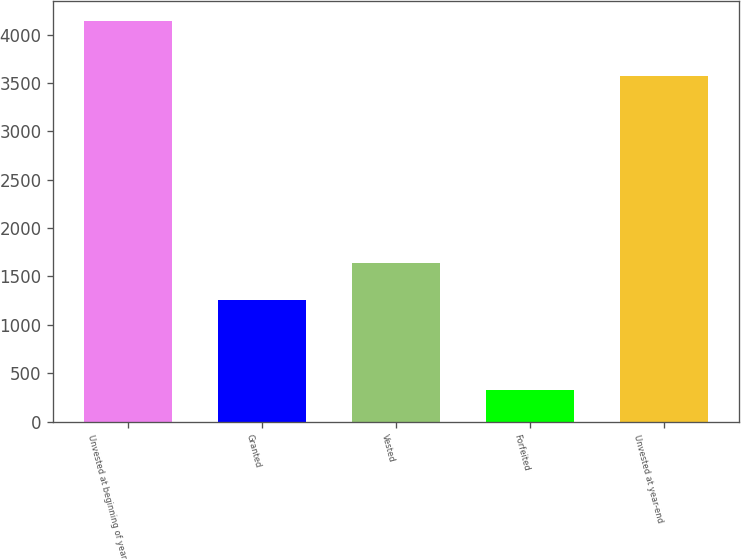<chart> <loc_0><loc_0><loc_500><loc_500><bar_chart><fcel>Unvested at beginning of year<fcel>Granted<fcel>Vested<fcel>Forfeited<fcel>Unvested at year-end<nl><fcel>4138<fcel>1254<fcel>1635.2<fcel>326<fcel>3571<nl></chart> 